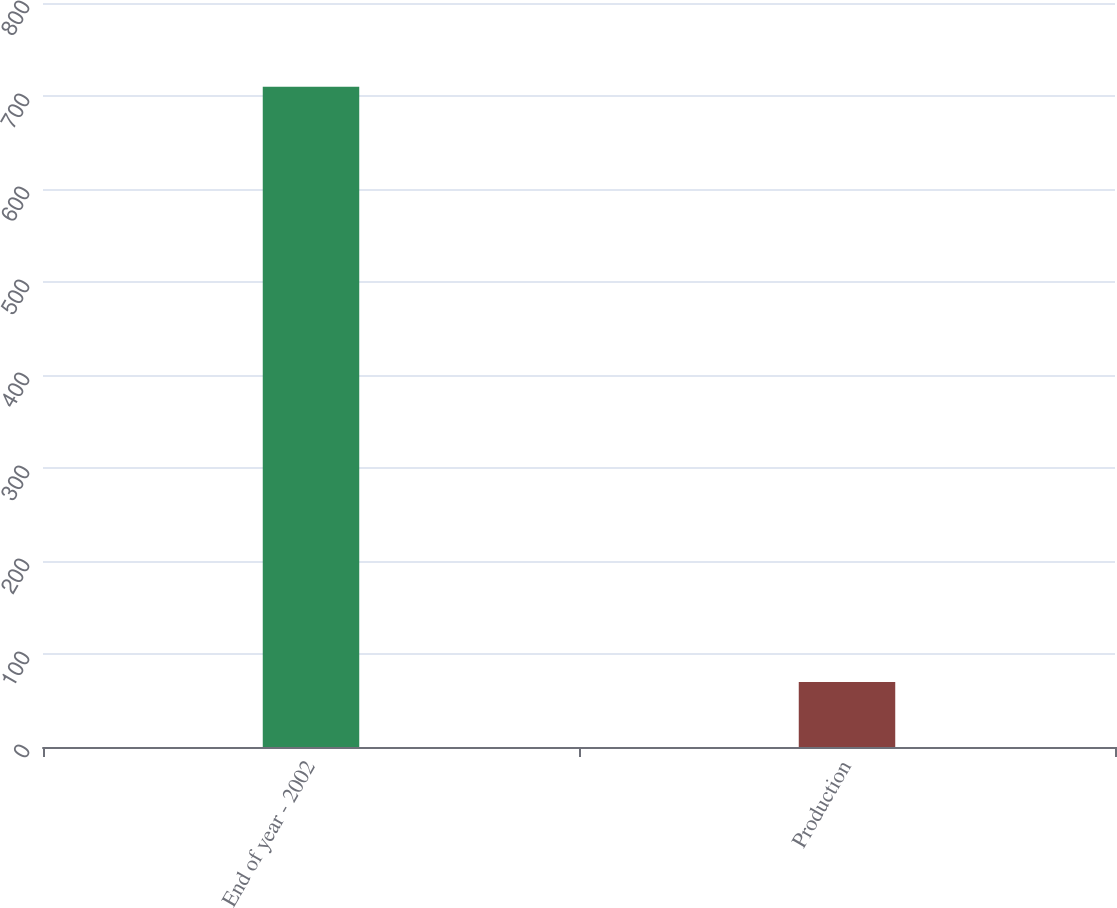<chart> <loc_0><loc_0><loc_500><loc_500><bar_chart><fcel>End of year - 2002<fcel>Production<nl><fcel>710<fcel>70<nl></chart> 